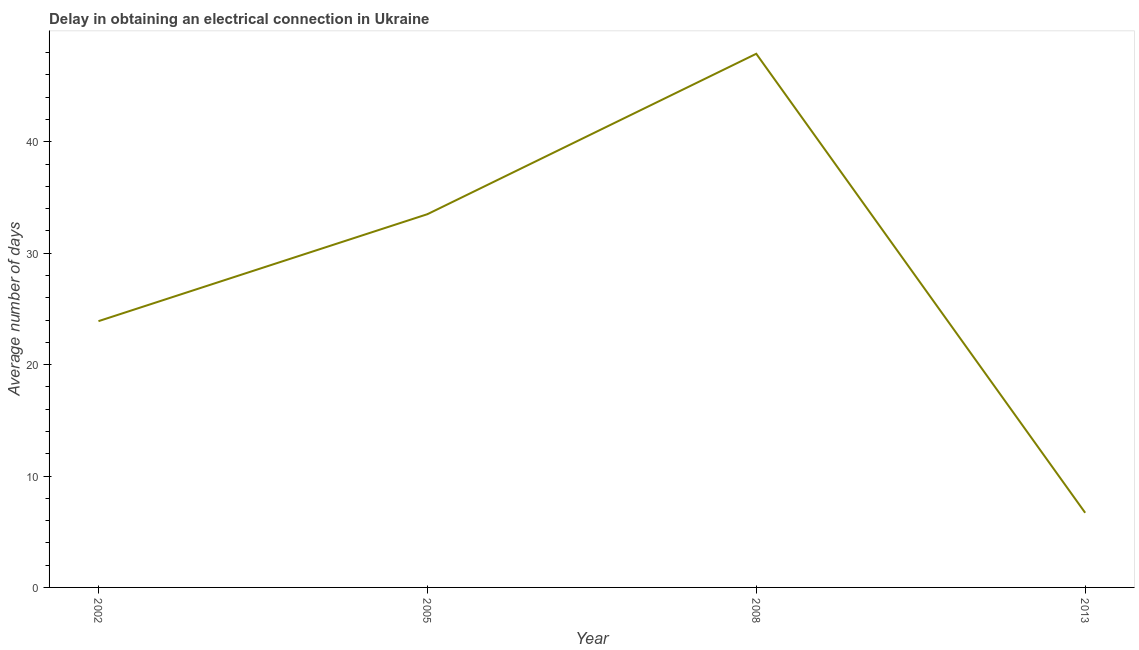What is the dalay in electrical connection in 2002?
Make the answer very short. 23.9. Across all years, what is the maximum dalay in electrical connection?
Provide a succinct answer. 47.9. Across all years, what is the minimum dalay in electrical connection?
Ensure brevity in your answer.  6.7. What is the sum of the dalay in electrical connection?
Offer a very short reply. 112. What is the average dalay in electrical connection per year?
Your response must be concise. 28. What is the median dalay in electrical connection?
Your answer should be very brief. 28.7. In how many years, is the dalay in electrical connection greater than 34 days?
Offer a terse response. 1. Do a majority of the years between 2013 and 2008 (inclusive) have dalay in electrical connection greater than 2 days?
Your answer should be very brief. No. What is the ratio of the dalay in electrical connection in 2002 to that in 2013?
Offer a terse response. 3.57. Is the difference between the dalay in electrical connection in 2008 and 2013 greater than the difference between any two years?
Ensure brevity in your answer.  Yes. What is the difference between the highest and the second highest dalay in electrical connection?
Your response must be concise. 14.4. What is the difference between the highest and the lowest dalay in electrical connection?
Give a very brief answer. 41.2. How many lines are there?
Give a very brief answer. 1. What is the difference between two consecutive major ticks on the Y-axis?
Offer a very short reply. 10. Does the graph contain any zero values?
Keep it short and to the point. No. What is the title of the graph?
Ensure brevity in your answer.  Delay in obtaining an electrical connection in Ukraine. What is the label or title of the X-axis?
Your response must be concise. Year. What is the label or title of the Y-axis?
Ensure brevity in your answer.  Average number of days. What is the Average number of days in 2002?
Offer a very short reply. 23.9. What is the Average number of days in 2005?
Provide a succinct answer. 33.5. What is the Average number of days of 2008?
Provide a succinct answer. 47.9. What is the difference between the Average number of days in 2002 and 2005?
Ensure brevity in your answer.  -9.6. What is the difference between the Average number of days in 2002 and 2008?
Keep it short and to the point. -24. What is the difference between the Average number of days in 2005 and 2008?
Ensure brevity in your answer.  -14.4. What is the difference between the Average number of days in 2005 and 2013?
Your answer should be very brief. 26.8. What is the difference between the Average number of days in 2008 and 2013?
Keep it short and to the point. 41.2. What is the ratio of the Average number of days in 2002 to that in 2005?
Make the answer very short. 0.71. What is the ratio of the Average number of days in 2002 to that in 2008?
Your response must be concise. 0.5. What is the ratio of the Average number of days in 2002 to that in 2013?
Keep it short and to the point. 3.57. What is the ratio of the Average number of days in 2005 to that in 2008?
Your answer should be very brief. 0.7. What is the ratio of the Average number of days in 2005 to that in 2013?
Offer a very short reply. 5. What is the ratio of the Average number of days in 2008 to that in 2013?
Your answer should be very brief. 7.15. 